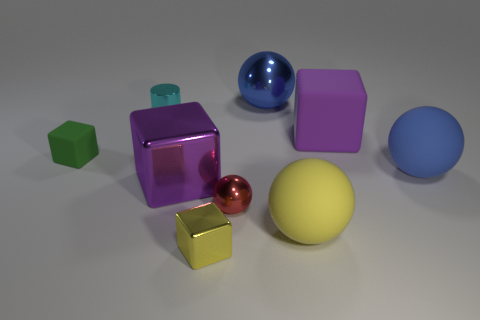What number of other things are the same size as the green object?
Ensure brevity in your answer.  3. Are there any other things that are made of the same material as the small red ball?
Offer a very short reply. Yes. There is a purple thing that is behind the blue ball in front of the blue thing behind the purple rubber thing; what is it made of?
Provide a short and direct response. Rubber. Is the shape of the small rubber thing the same as the yellow rubber object?
Keep it short and to the point. No. There is a yellow object that is the same shape as the tiny red metallic object; what is its material?
Keep it short and to the point. Rubber. How many tiny matte blocks have the same color as the metal cylinder?
Make the answer very short. 0. There is a blue thing that is made of the same material as the yellow cube; what is its size?
Provide a succinct answer. Large. What number of red things are either big metallic spheres or tiny blocks?
Your answer should be very brief. 0. There is a big ball behind the cylinder; what number of yellow matte balls are in front of it?
Ensure brevity in your answer.  1. Are there more rubber blocks in front of the tiny red thing than small yellow things that are behind the blue rubber object?
Your answer should be very brief. No. 